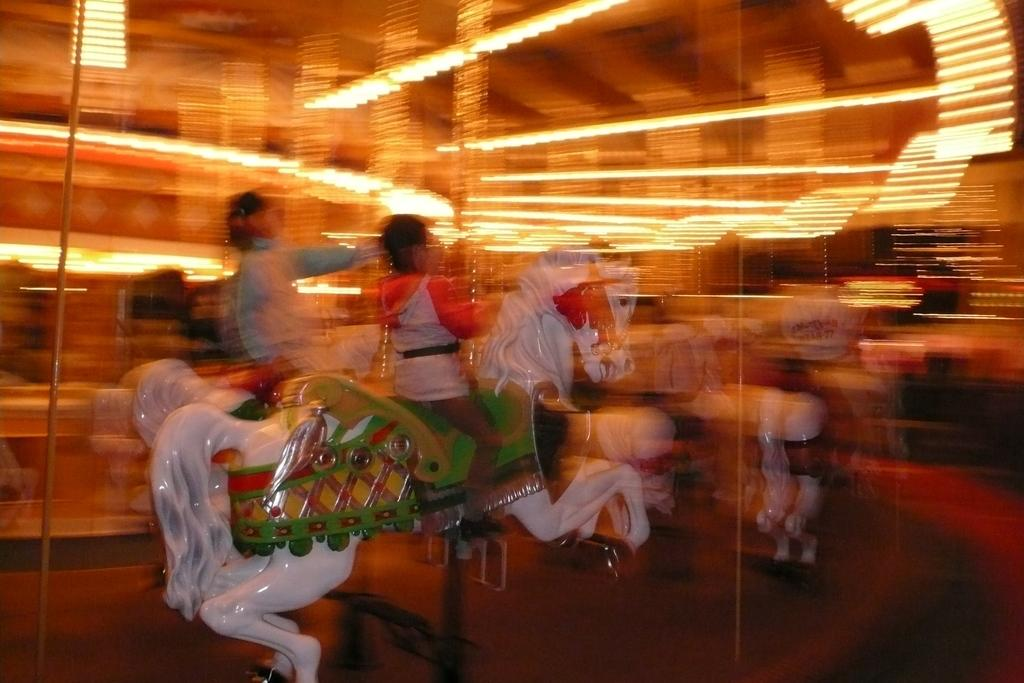What are the people doing in the image? The people are sitting on a toy horse in the image. How clear is the image of the people? The image of the people is blurred. What objects can be seen in the background of the image? There are poles in the image. What else can be seen in the image besides the people and poles? There are lights in the image. What happens to the knee of the person sitting on the toy horse when it bursts in the image? There is no indication in the image that the toy horse bursts, nor is there any mention of a person's knee. 